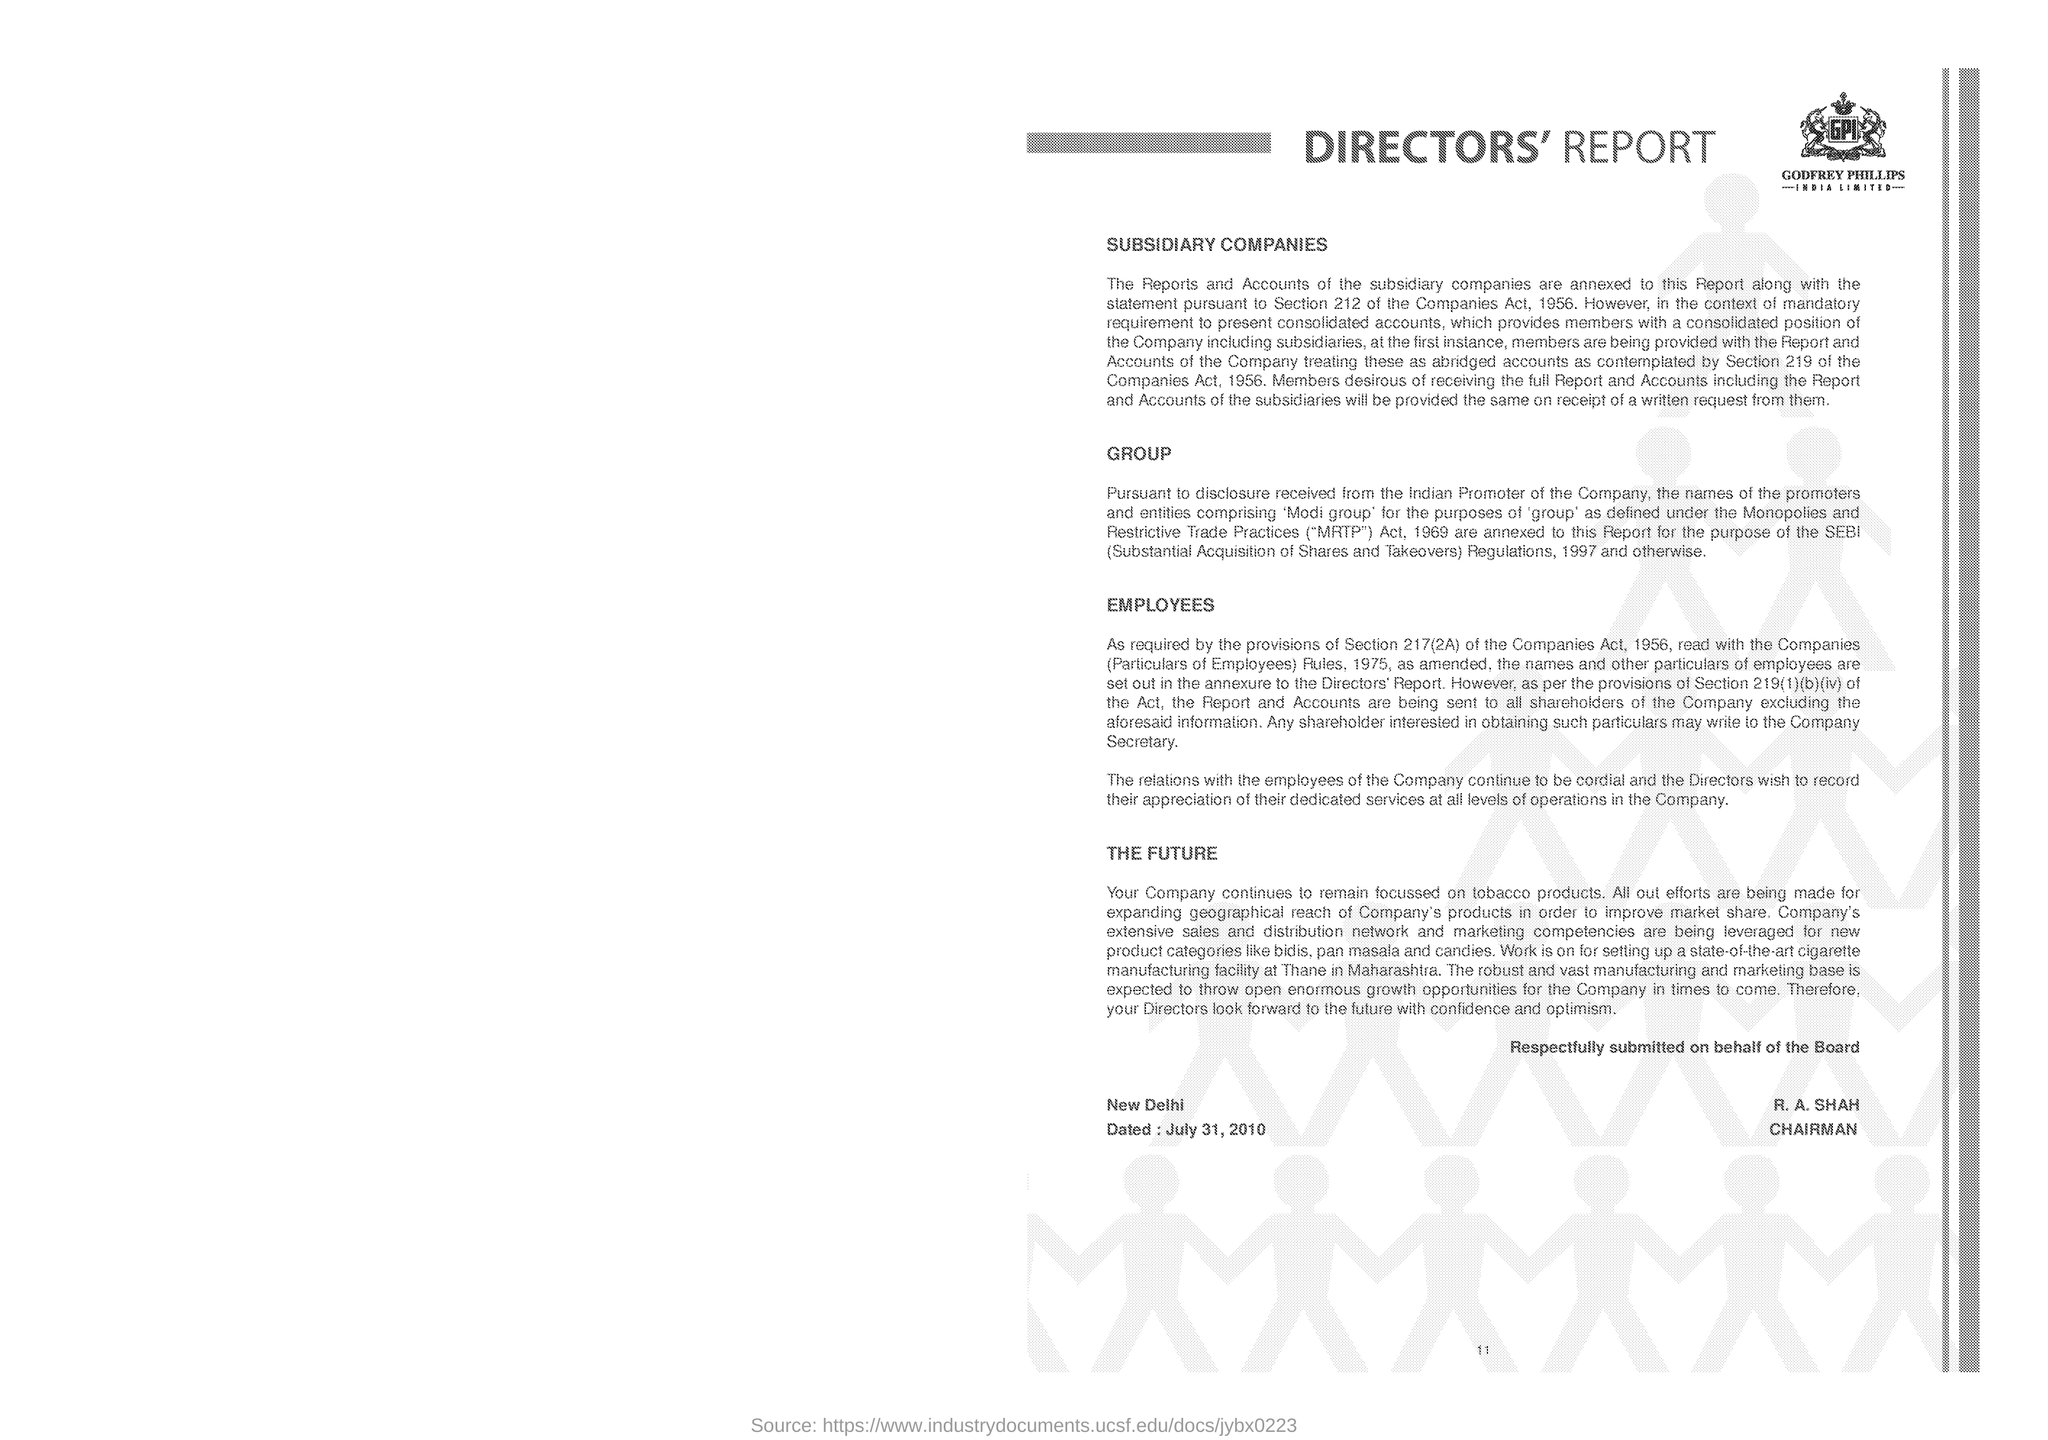What is written within the logo?
Provide a succinct answer. GPI. What is the heading of the document?
Make the answer very short. DIRECTORS' REPORT. What is the first side heading given?
Provide a short and direct response. SUBSIDIARY COMPANIES. Mention the page number given at the bottom of the page?
Keep it short and to the point. 11. What is the expansion of "MRTP"?
Your response must be concise. Monopolies and Restrictive Trade Practices. Mention the name of place given above "Dated"?
Offer a terse response. New Delhi. What is the designation of R.A. SHAH?
Give a very brief answer. CHAIRMAN. In which place "work is on for setting up a state-of-the-art cigarette manufacturing facility"?
Your answer should be very brief. Thane in Maharashtra. 